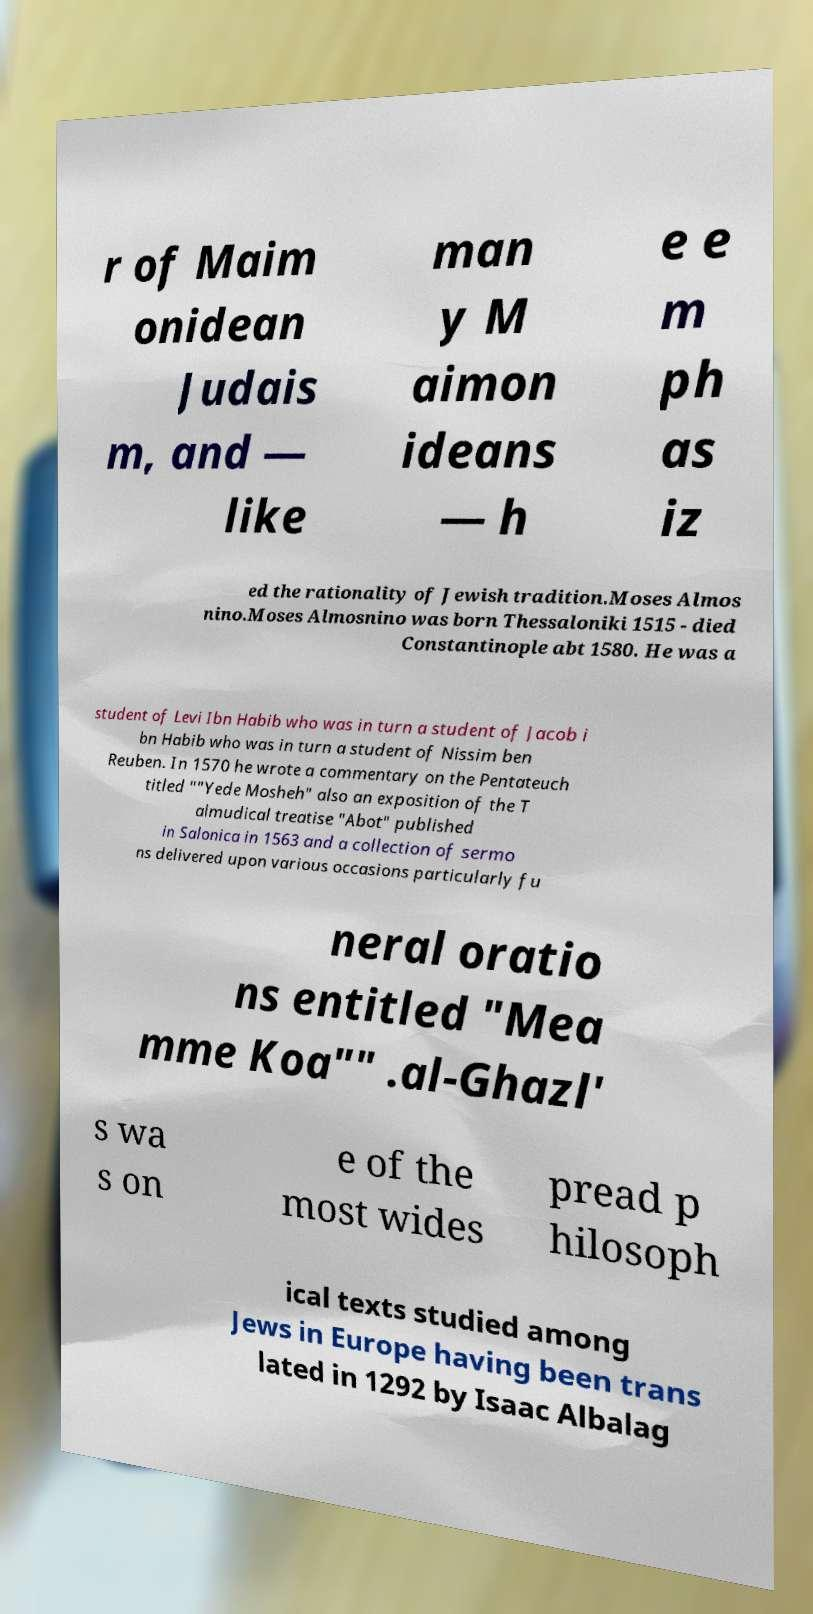For documentation purposes, I need the text within this image transcribed. Could you provide that? r of Maim onidean Judais m, and — like man y M aimon ideans — h e e m ph as iz ed the rationality of Jewish tradition.Moses Almos nino.Moses Almosnino was born Thessaloniki 1515 - died Constantinople abt 1580. He was a student of Levi Ibn Habib who was in turn a student of Jacob i bn Habib who was in turn a student of Nissim ben Reuben. In 1570 he wrote a commentary on the Pentateuch titled ""Yede Mosheh" also an exposition of the T almudical treatise "Abot" published in Salonica in 1563 and a collection of sermo ns delivered upon various occasions particularly fu neral oratio ns entitled "Mea mme Koa"" .al-Ghazl' s wa s on e of the most wides pread p hilosoph ical texts studied among Jews in Europe having been trans lated in 1292 by Isaac Albalag 